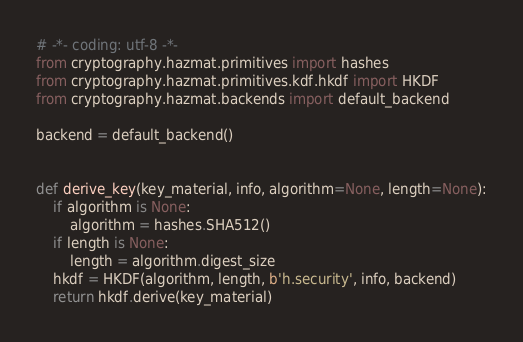<code> <loc_0><loc_0><loc_500><loc_500><_Python_># -*- coding: utf-8 -*-
from cryptography.hazmat.primitives import hashes
from cryptography.hazmat.primitives.kdf.hkdf import HKDF
from cryptography.hazmat.backends import default_backend

backend = default_backend()


def derive_key(key_material, info, algorithm=None, length=None):
    if algorithm is None:
        algorithm = hashes.SHA512()
    if length is None:
        length = algorithm.digest_size
    hkdf = HKDF(algorithm, length, b'h.security', info, backend)
    return hkdf.derive(key_material)
</code> 